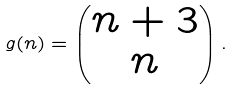Convert formula to latex. <formula><loc_0><loc_0><loc_500><loc_500>g ( n ) = \begin{pmatrix} n + 3 \\ n \end{pmatrix} .</formula> 